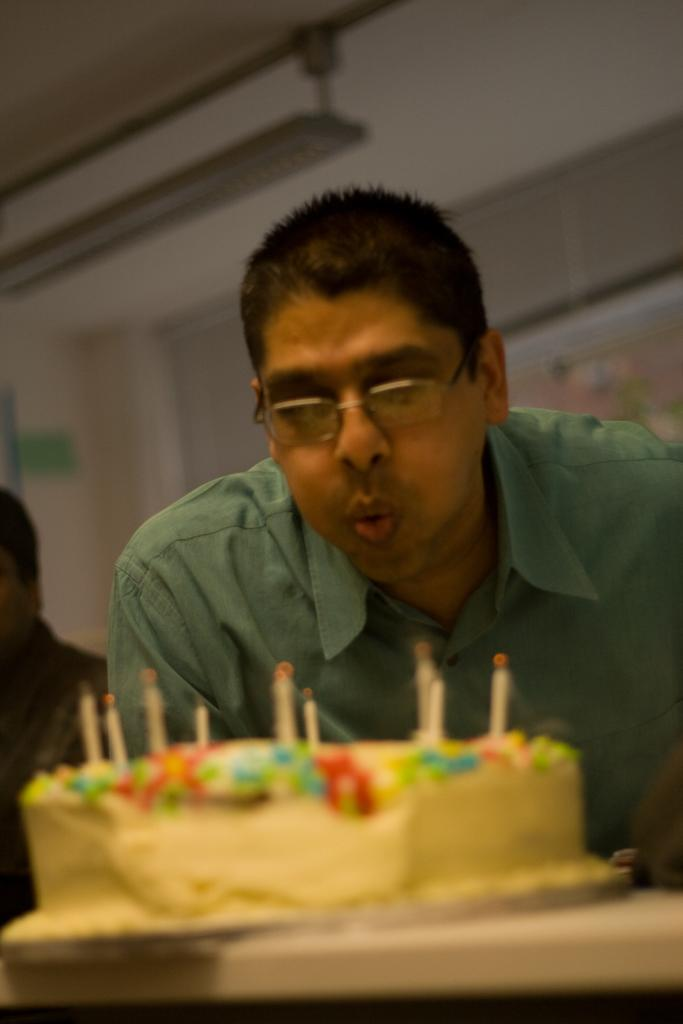How many people are in the image? There are a few people in the image. What is on the table in the image? There is a cake with candles in the image. What can be seen in the background of the image? There is a wall in the background of the image. Can you describe the object on the wall in the background? There is an object on the wall in the background, but the specific details are not provided in the facts. What type of dog is sitting next to the cake in the image? There is no dog present in the image; it features a few people and a cake with candles. Who is the manager of the event in the image? The facts provided do not mention any event or manager, so this information cannot be determined from the image. 